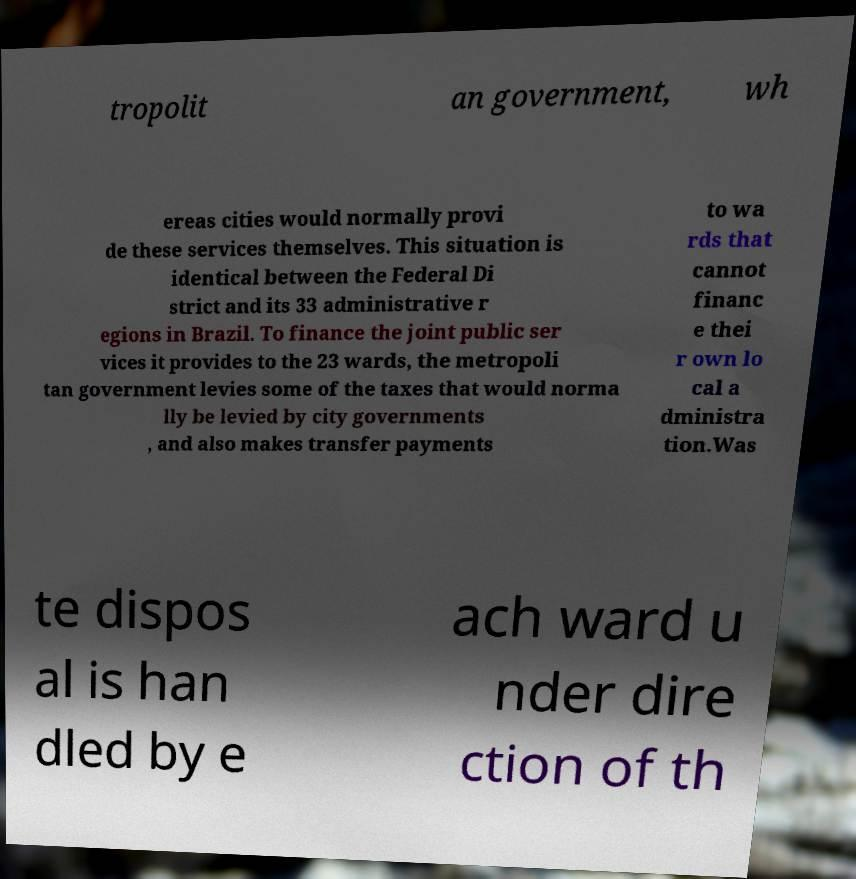For documentation purposes, I need the text within this image transcribed. Could you provide that? tropolit an government, wh ereas cities would normally provi de these services themselves. This situation is identical between the Federal Di strict and its 33 administrative r egions in Brazil. To finance the joint public ser vices it provides to the 23 wards, the metropoli tan government levies some of the taxes that would norma lly be levied by city governments , and also makes transfer payments to wa rds that cannot financ e thei r own lo cal a dministra tion.Was te dispos al is han dled by e ach ward u nder dire ction of th 